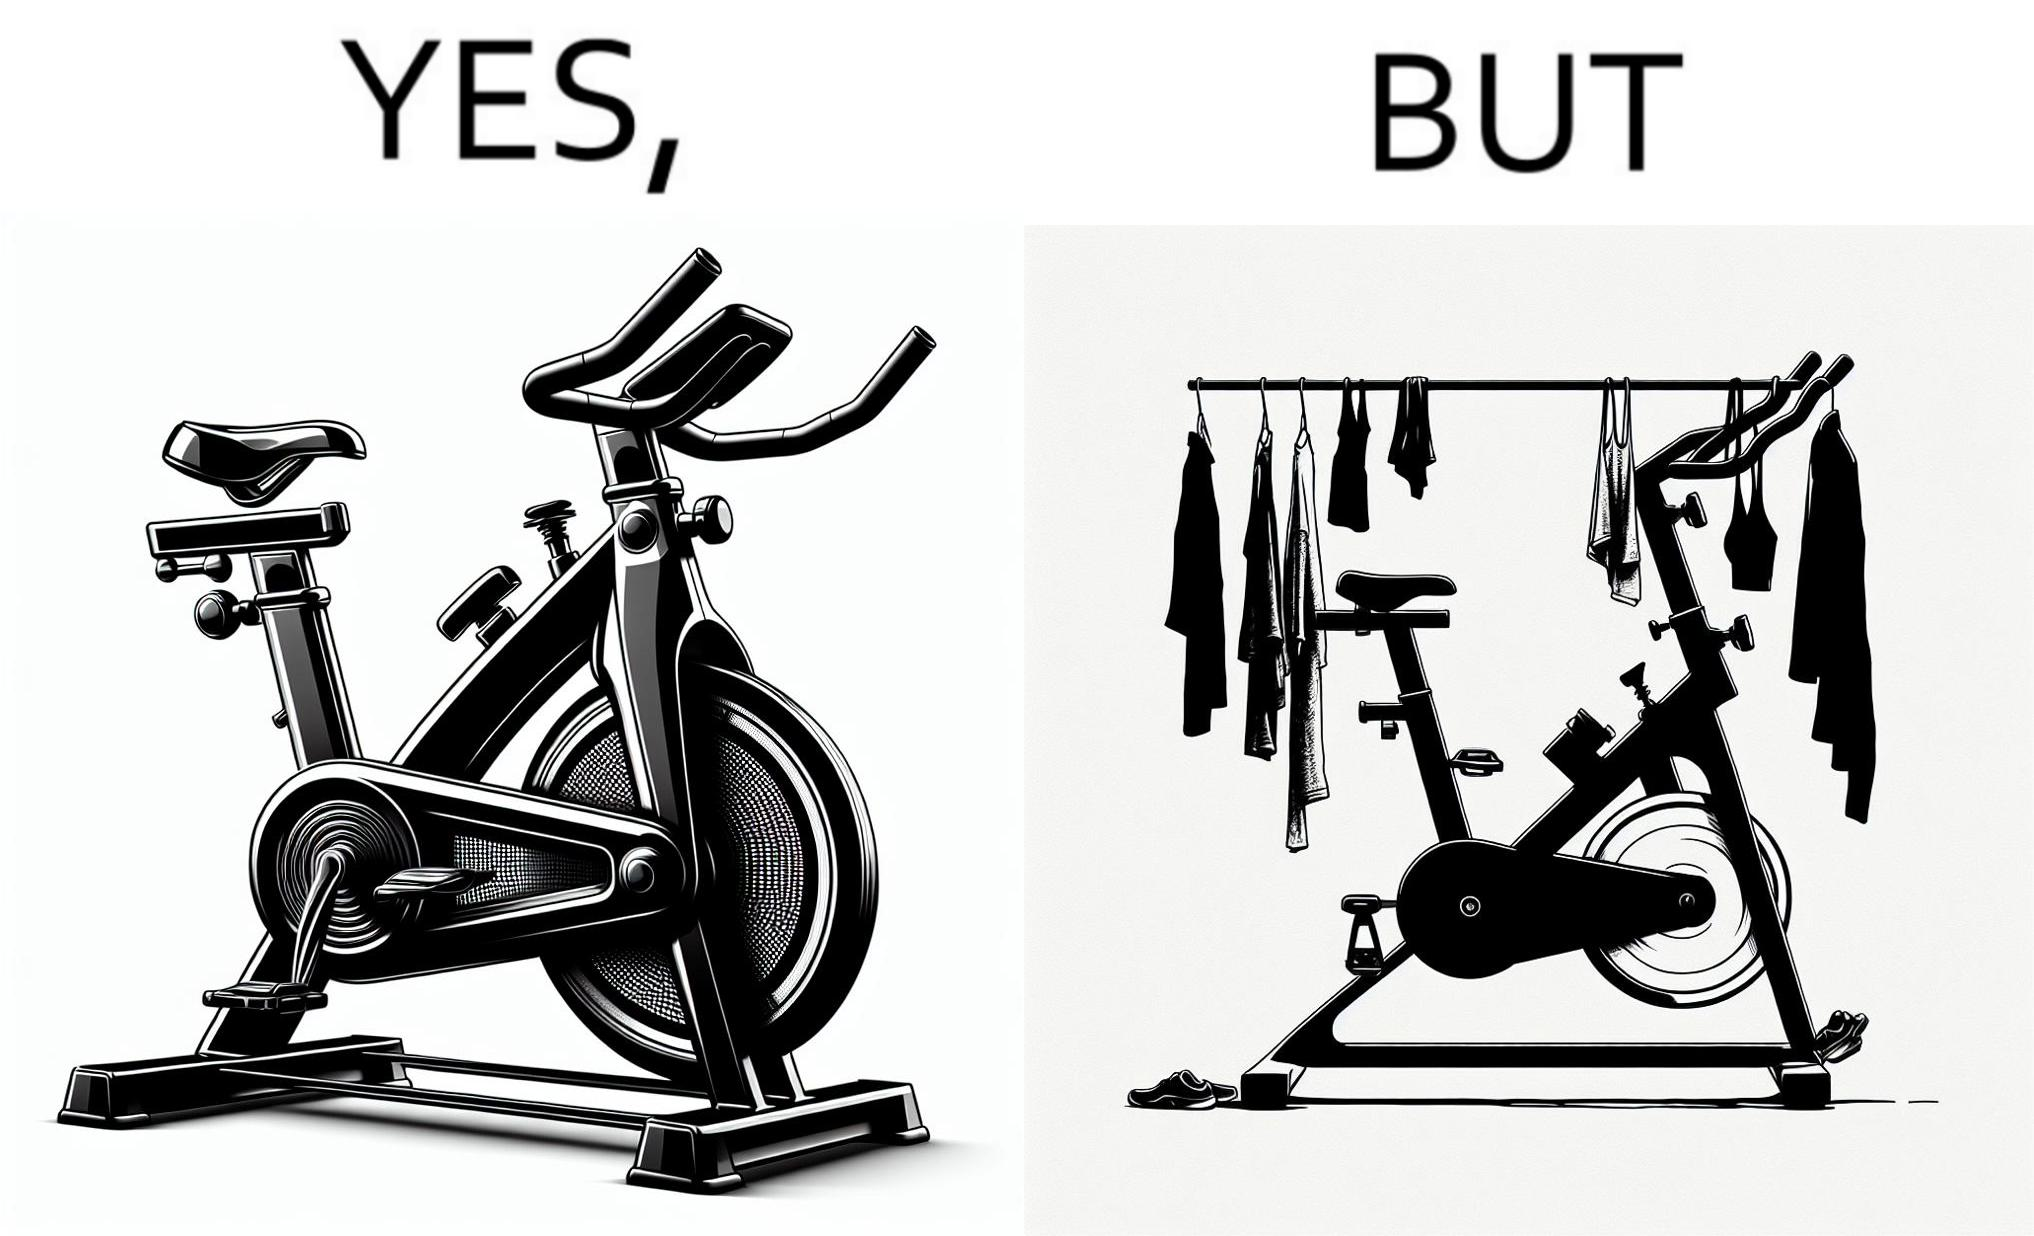What is the satirical meaning behind this image? The images are funny since they show an exercise bike has been bought but is not being used for its purpose, that is, exercising. It is rather being used to hang clothes, bags and other items 